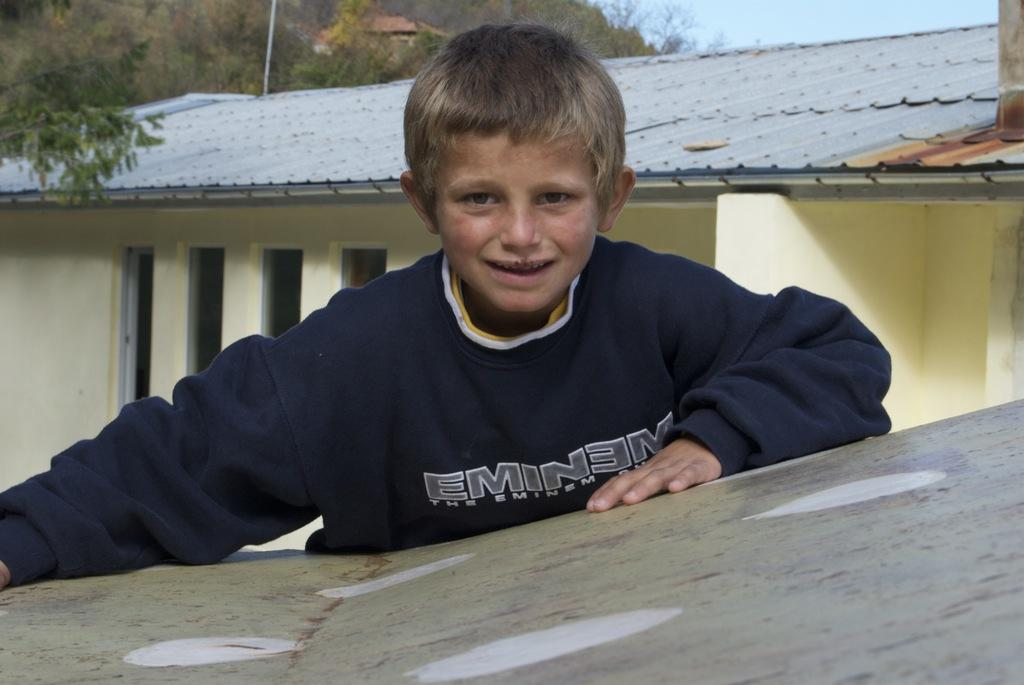What is the main subject of the image? The main subject of the image is a kid. What is the kid wearing? The kid is wearing a blue dress. What is the kid doing in the image? The kid has his hands on an object. What can be seen behind the kid? There is a house behind the kid. What type of natural scenery is visible in the background? There are trees in the background of the image. Can you see a tiger walking through the trees in the background of the image? No, there is no tiger present in the image. 